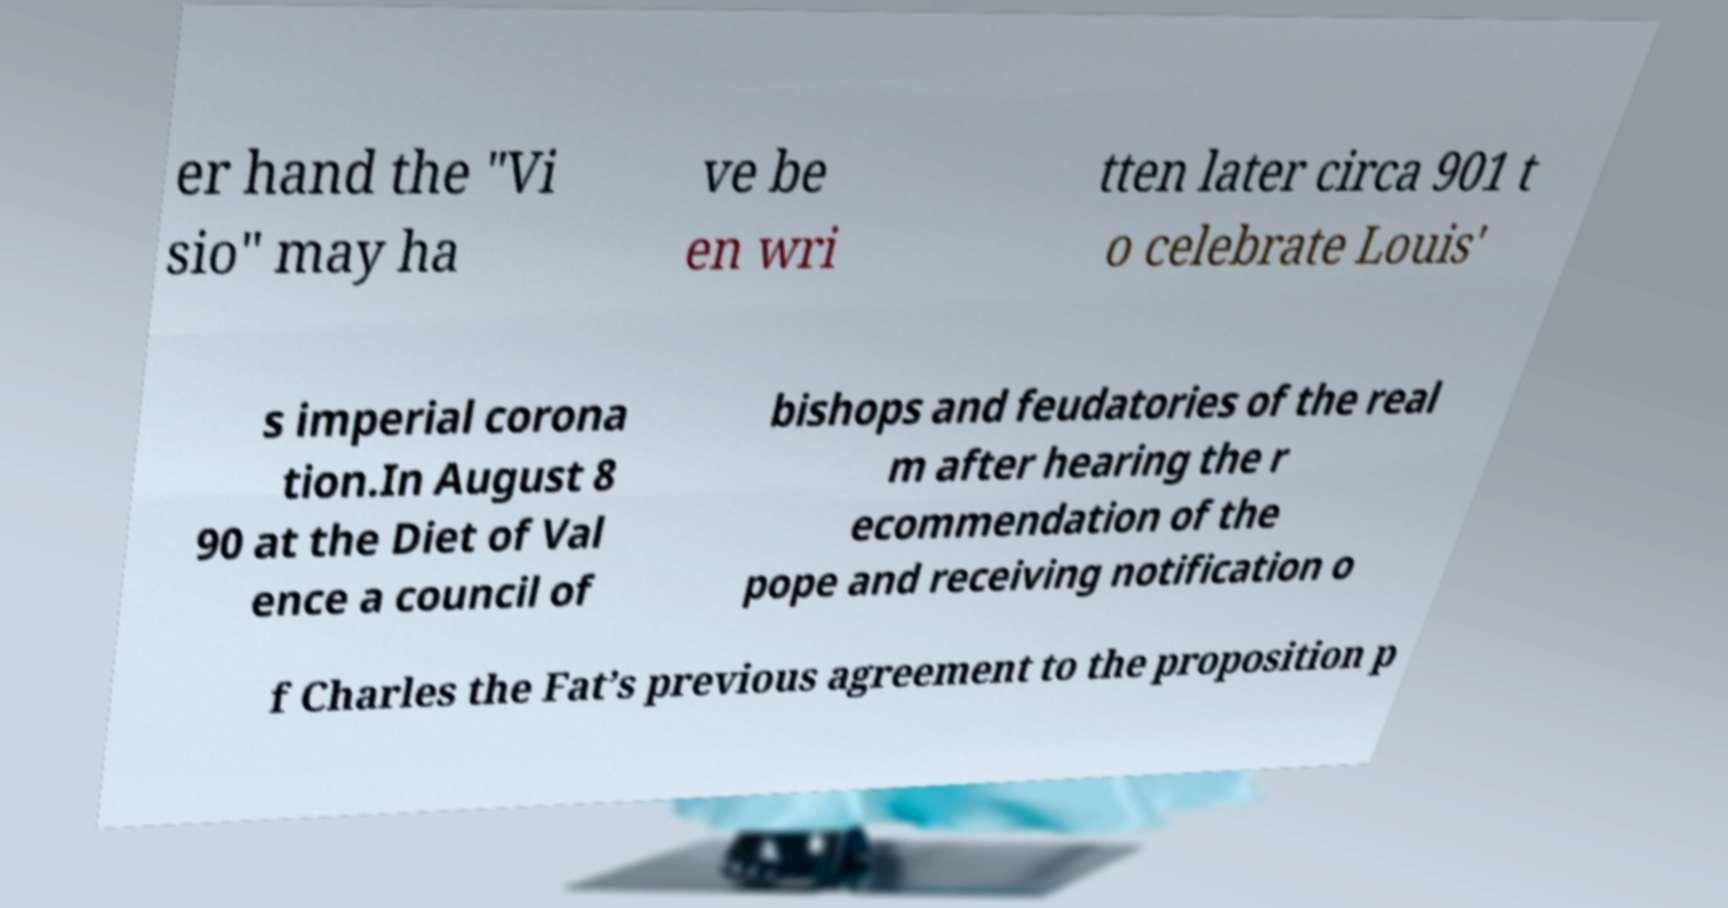I need the written content from this picture converted into text. Can you do that? er hand the "Vi sio" may ha ve be en wri tten later circa 901 t o celebrate Louis' s imperial corona tion.In August 8 90 at the Diet of Val ence a council of bishops and feudatories of the real m after hearing the r ecommendation of the pope and receiving notification o f Charles the Fat’s previous agreement to the proposition p 